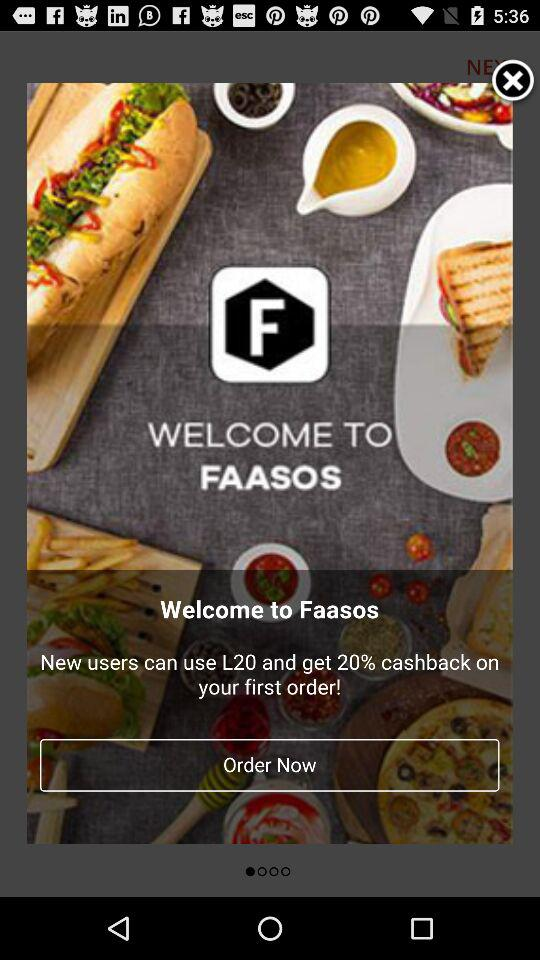What is the application name? The application name is "FAASOS". 